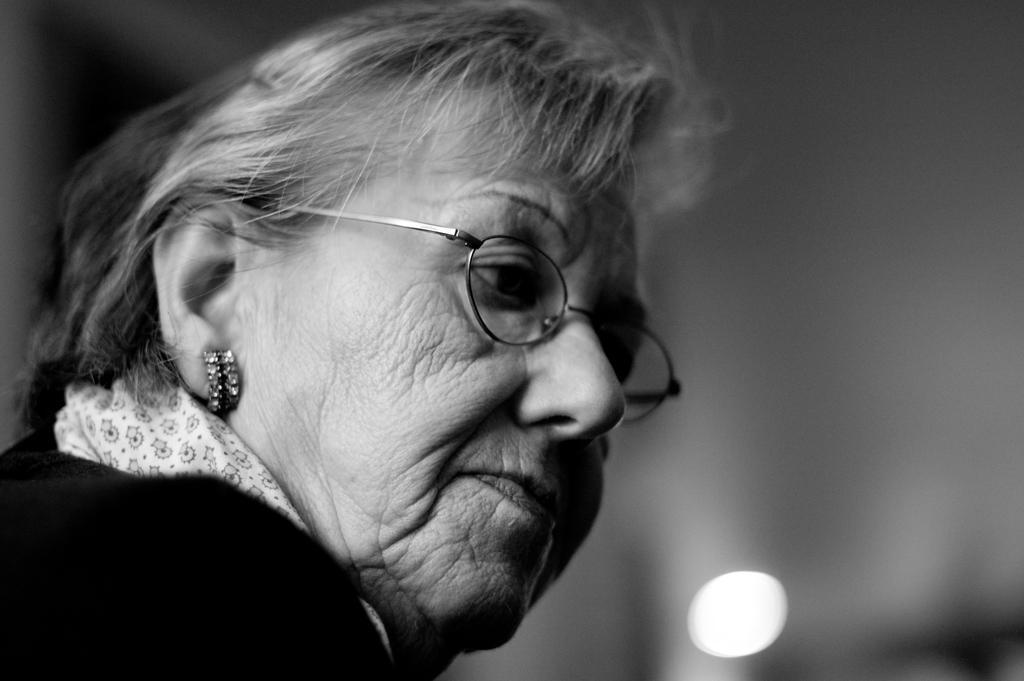In one or two sentences, can you explain what this image depicts? This is a black and white image. On the left side, there is a woman, wearing a spectacle and watching something. On the right side, there is light. And the background is blurred. 